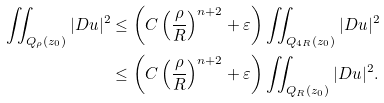<formula> <loc_0><loc_0><loc_500><loc_500>\iint _ { Q _ { \rho } ( z _ { 0 } ) } | D u | ^ { 2 } & \leq \left ( C \left ( \frac { \rho } { R } \right ) ^ { n + 2 } + \varepsilon \right ) \iint _ { Q _ { 4 R } ( z _ { 0 } ) } | D u | ^ { 2 } \\ & \leq \left ( C \left ( \frac { \rho } { R } \right ) ^ { n + 2 } + \varepsilon \right ) \iint _ { Q _ { R } ( z _ { 0 } ) } | D u | ^ { 2 } .</formula> 